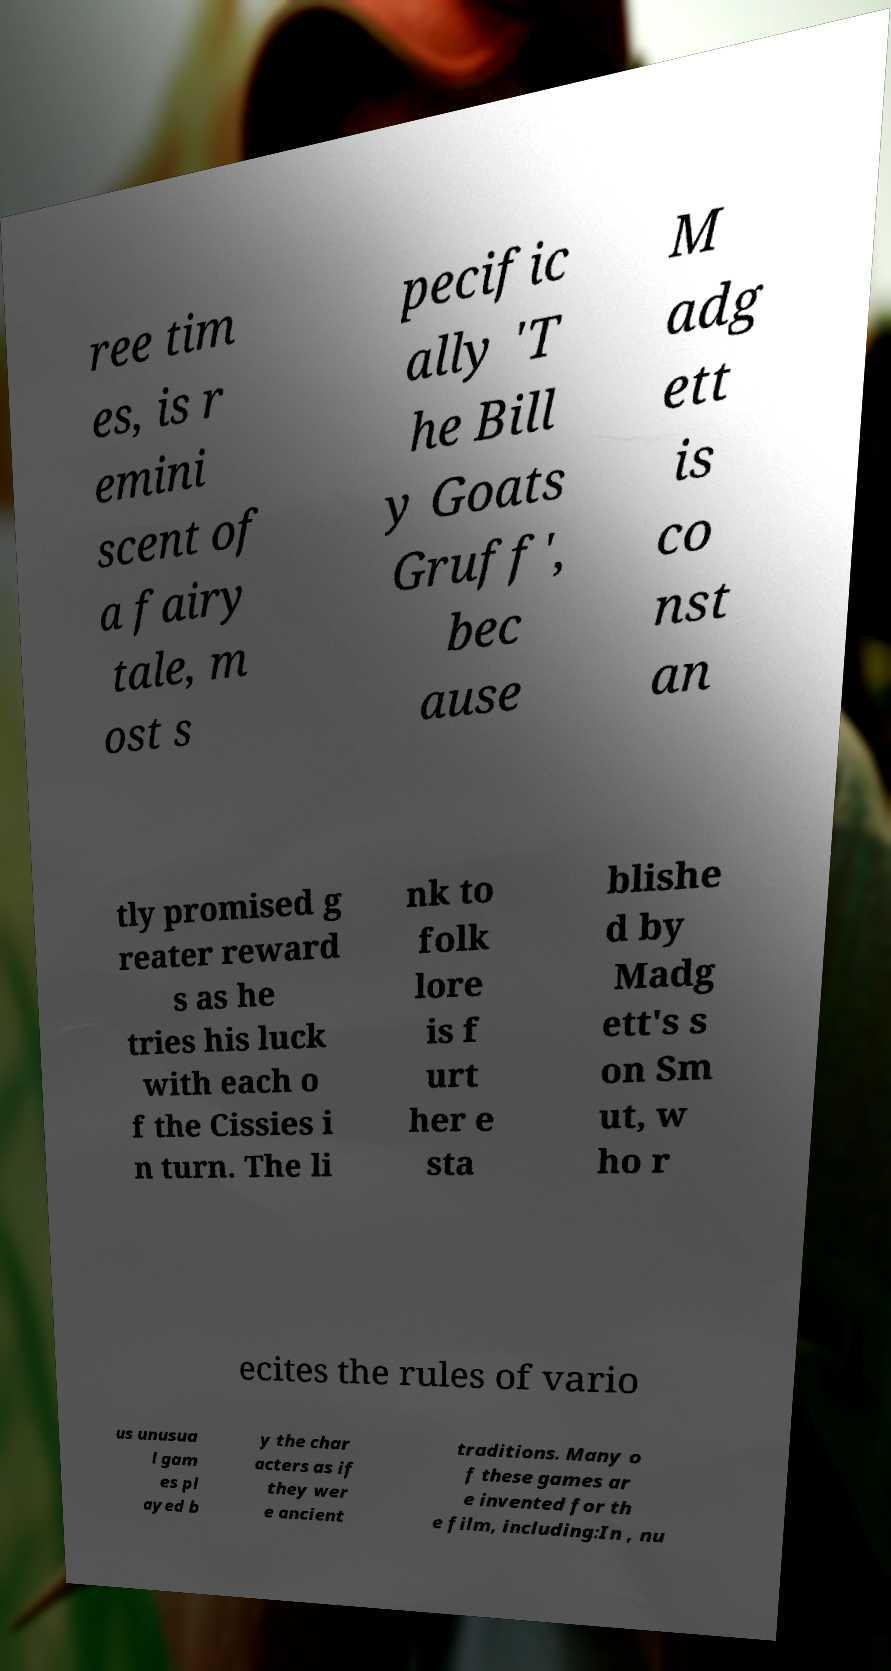For documentation purposes, I need the text within this image transcribed. Could you provide that? ree tim es, is r emini scent of a fairy tale, m ost s pecific ally 'T he Bill y Goats Gruff', bec ause M adg ett is co nst an tly promised g reater reward s as he tries his luck with each o f the Cissies i n turn. The li nk to folk lore is f urt her e sta blishe d by Madg ett's s on Sm ut, w ho r ecites the rules of vario us unusua l gam es pl ayed b y the char acters as if they wer e ancient traditions. Many o f these games ar e invented for th e film, including:In , nu 